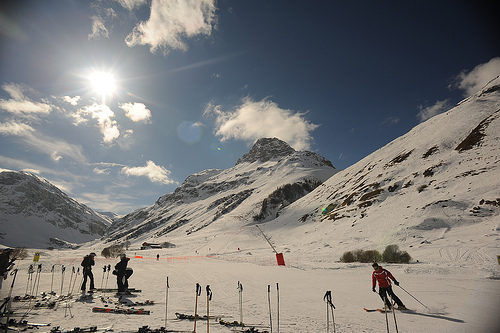Are there any cars or bulbs?
Answer the question using a single word or phrase. No What color is the coat that the people are in? Red Are there either orange fences or bowls? Yes Which side is the fence on, the right or the left? Left Are there people to the right of the fence? No 